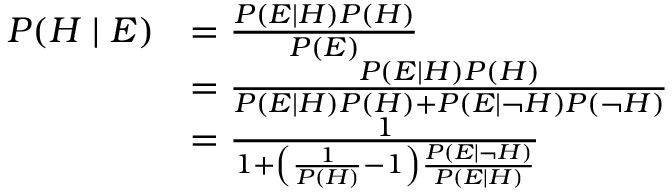Convert formula to latex. <formula><loc_0><loc_0><loc_500><loc_500>{ \begin{array} { r l } { P ( H | E ) } & { = { \frac { P ( E | H ) P ( H ) } { P ( E ) } } } \\ & { = { \frac { P ( E | H ) P ( H ) } { P ( E | H ) P ( H ) + P ( E | \neg H ) P ( \neg H ) } } } \\ & { = { \frac { 1 } { 1 + \left ( { \frac { 1 } { P ( H ) } } - 1 \right ) { \frac { P ( E | \neg H ) } { P ( E | H ) } } } } } \end{array} }</formula> 